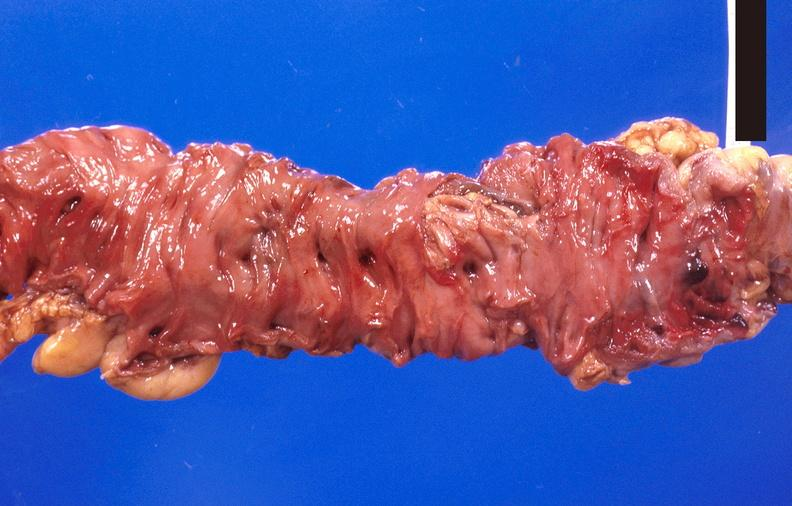s gastrointestinal present?
Answer the question using a single word or phrase. Yes 